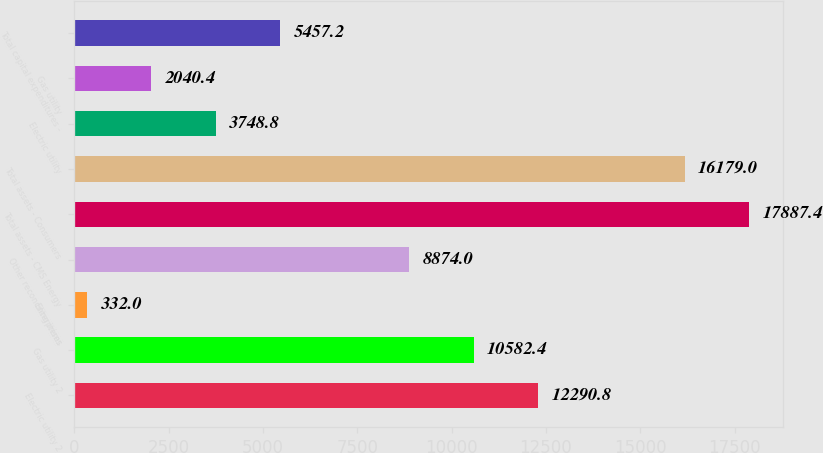Convert chart. <chart><loc_0><loc_0><loc_500><loc_500><bar_chart><fcel>Electric utility 2<fcel>Gas utility 2<fcel>Enterprises<fcel>Other reconciling items<fcel>Total assets - CMS Energy<fcel>Total assets - Consumers<fcel>Electric utility<fcel>Gas utility<fcel>Total capital expenditures -<nl><fcel>12290.8<fcel>10582.4<fcel>332<fcel>8874<fcel>17887.4<fcel>16179<fcel>3748.8<fcel>2040.4<fcel>5457.2<nl></chart> 